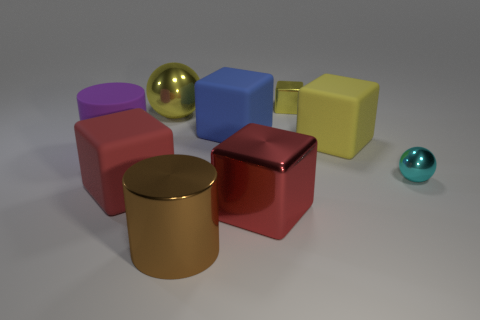Subtract 2 cubes. How many cubes are left? 3 Subtract all blue blocks. How many blocks are left? 4 Subtract all green cubes. Subtract all gray cylinders. How many cubes are left? 5 Add 1 large gray rubber balls. How many objects exist? 10 Subtract all spheres. How many objects are left? 7 Subtract all purple matte cylinders. Subtract all big red rubber blocks. How many objects are left? 7 Add 3 blue blocks. How many blue blocks are left? 4 Add 9 big green blocks. How many big green blocks exist? 9 Subtract 0 cyan cylinders. How many objects are left? 9 